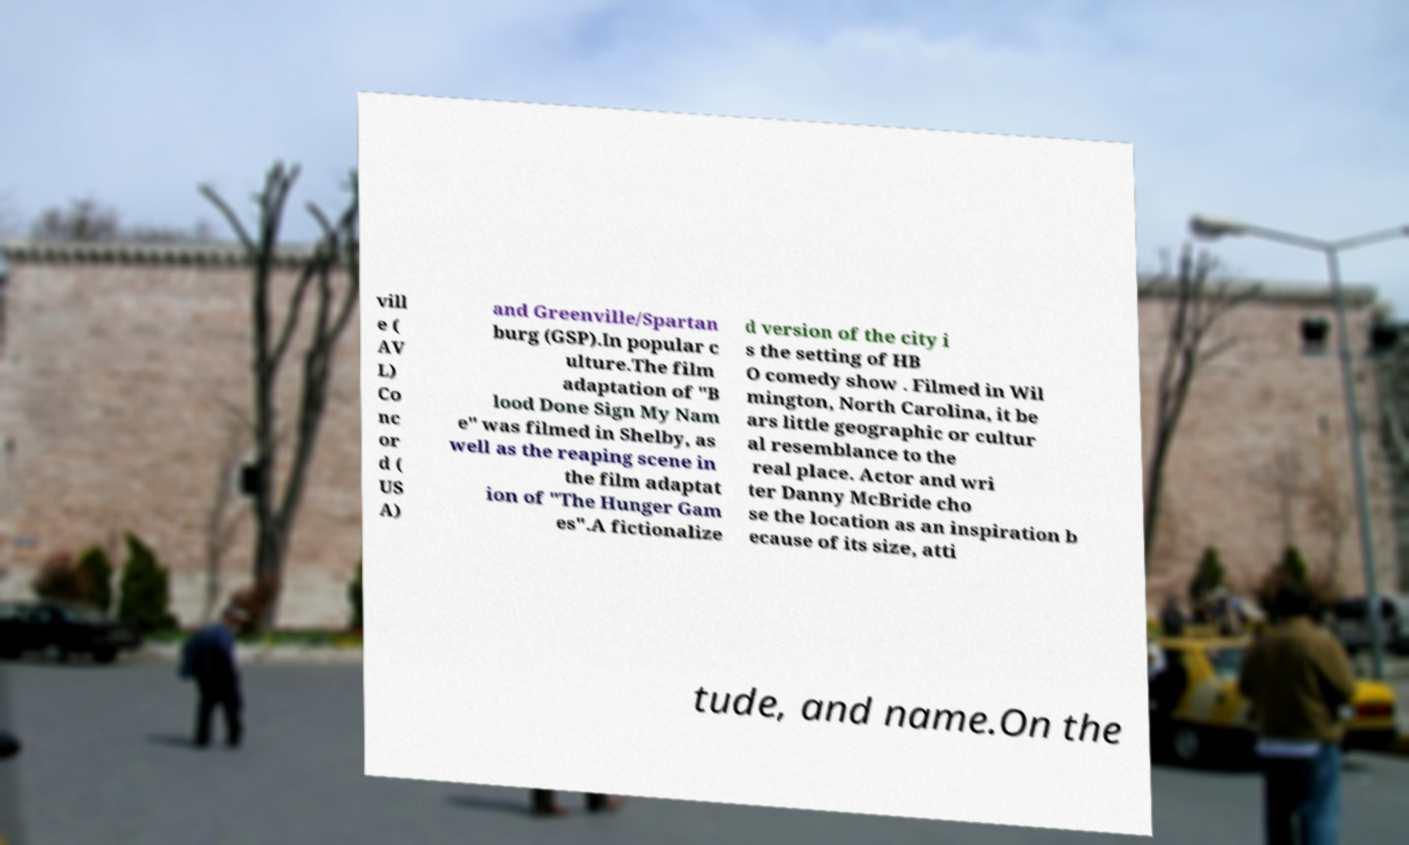Can you accurately transcribe the text from the provided image for me? vill e ( AV L) Co nc or d ( US A) and Greenville/Spartan burg (GSP).In popular c ulture.The film adaptation of "B lood Done Sign My Nam e" was filmed in Shelby, as well as the reaping scene in the film adaptat ion of "The Hunger Gam es".A fictionalize d version of the city i s the setting of HB O comedy show . Filmed in Wil mington, North Carolina, it be ars little geographic or cultur al resemblance to the real place. Actor and wri ter Danny McBride cho se the location as an inspiration b ecause of its size, atti tude, and name.On the 